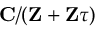Convert formula to latex. <formula><loc_0><loc_0><loc_500><loc_500>C / ( Z + Z \tau )</formula> 